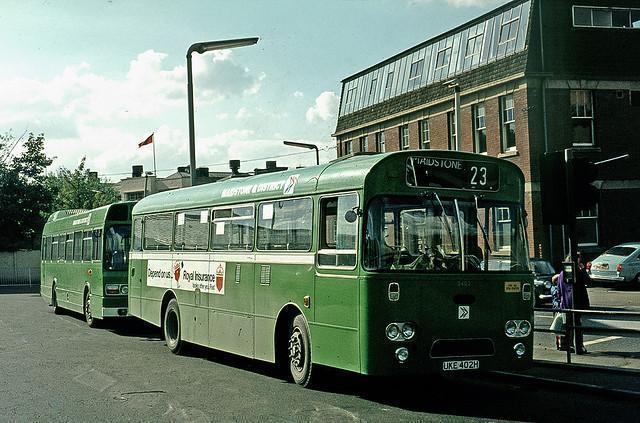What is the sum of each individual digit on the top of the bus?
Choose the correct response, then elucidate: 'Answer: answer
Rationale: rationale.'
Options: 23, five, 223, 32. Answer: five.
Rationale: Two plus three equals. 